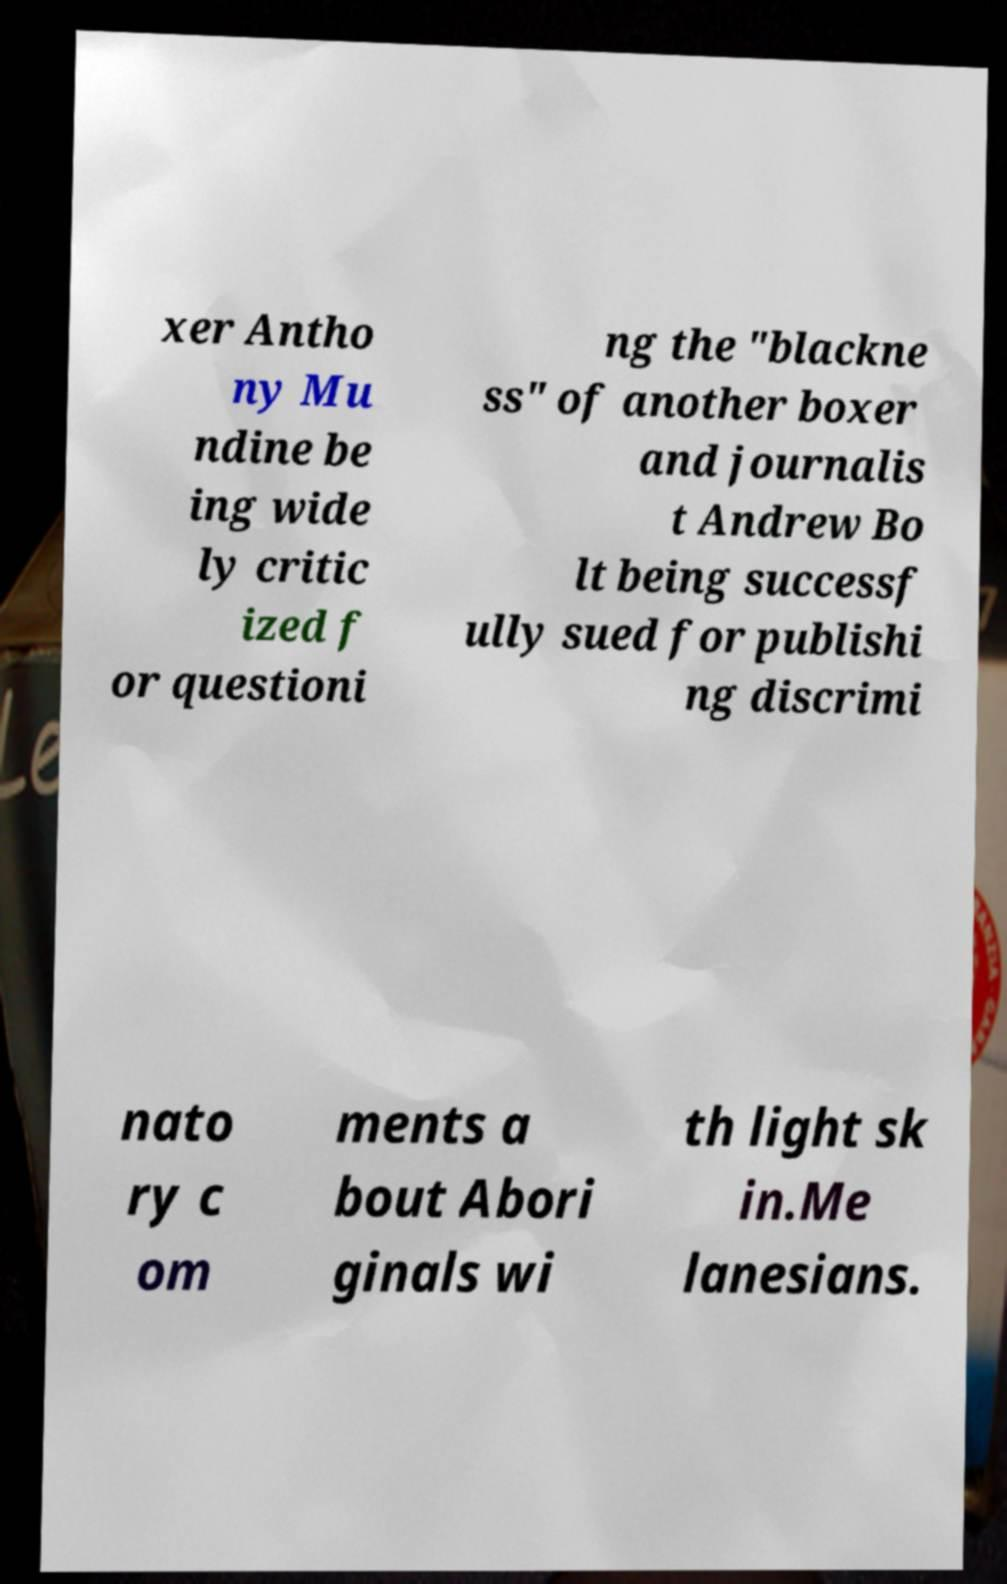Please read and relay the text visible in this image. What does it say? xer Antho ny Mu ndine be ing wide ly critic ized f or questioni ng the "blackne ss" of another boxer and journalis t Andrew Bo lt being successf ully sued for publishi ng discrimi nato ry c om ments a bout Abori ginals wi th light sk in.Me lanesians. 